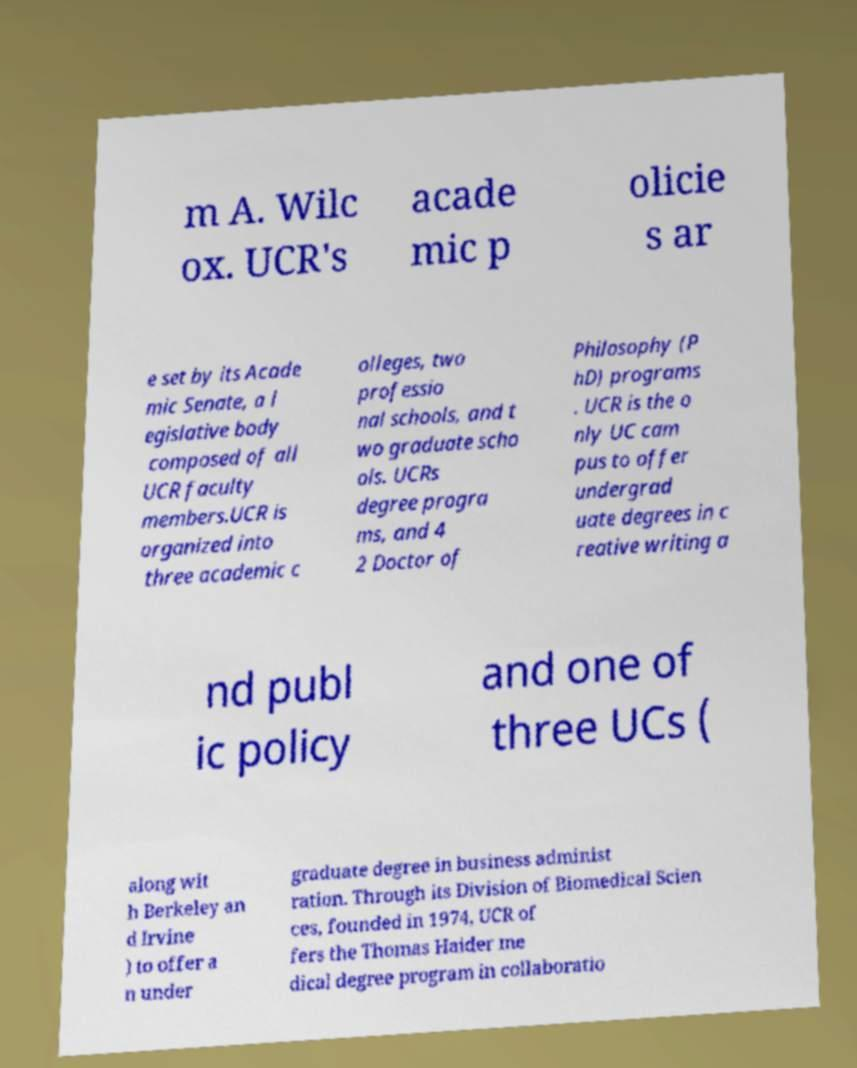Please read and relay the text visible in this image. What does it say? m A. Wilc ox. UCR's acade mic p olicie s ar e set by its Acade mic Senate, a l egislative body composed of all UCR faculty members.UCR is organized into three academic c olleges, two professio nal schools, and t wo graduate scho ols. UCRs degree progra ms, and 4 2 Doctor of Philosophy (P hD) programs . UCR is the o nly UC cam pus to offer undergrad uate degrees in c reative writing a nd publ ic policy and one of three UCs ( along wit h Berkeley an d Irvine ) to offer a n under graduate degree in business administ ration. Through its Division of Biomedical Scien ces, founded in 1974, UCR of fers the Thomas Haider me dical degree program in collaboratio 